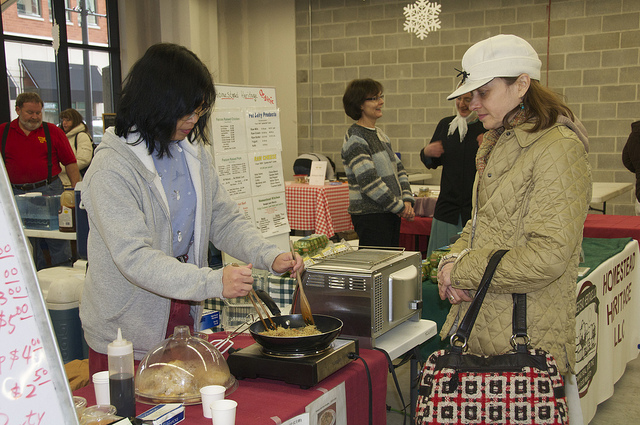Please transcribe the text information in this image. 00 LLC $5 3 00 oo 00 